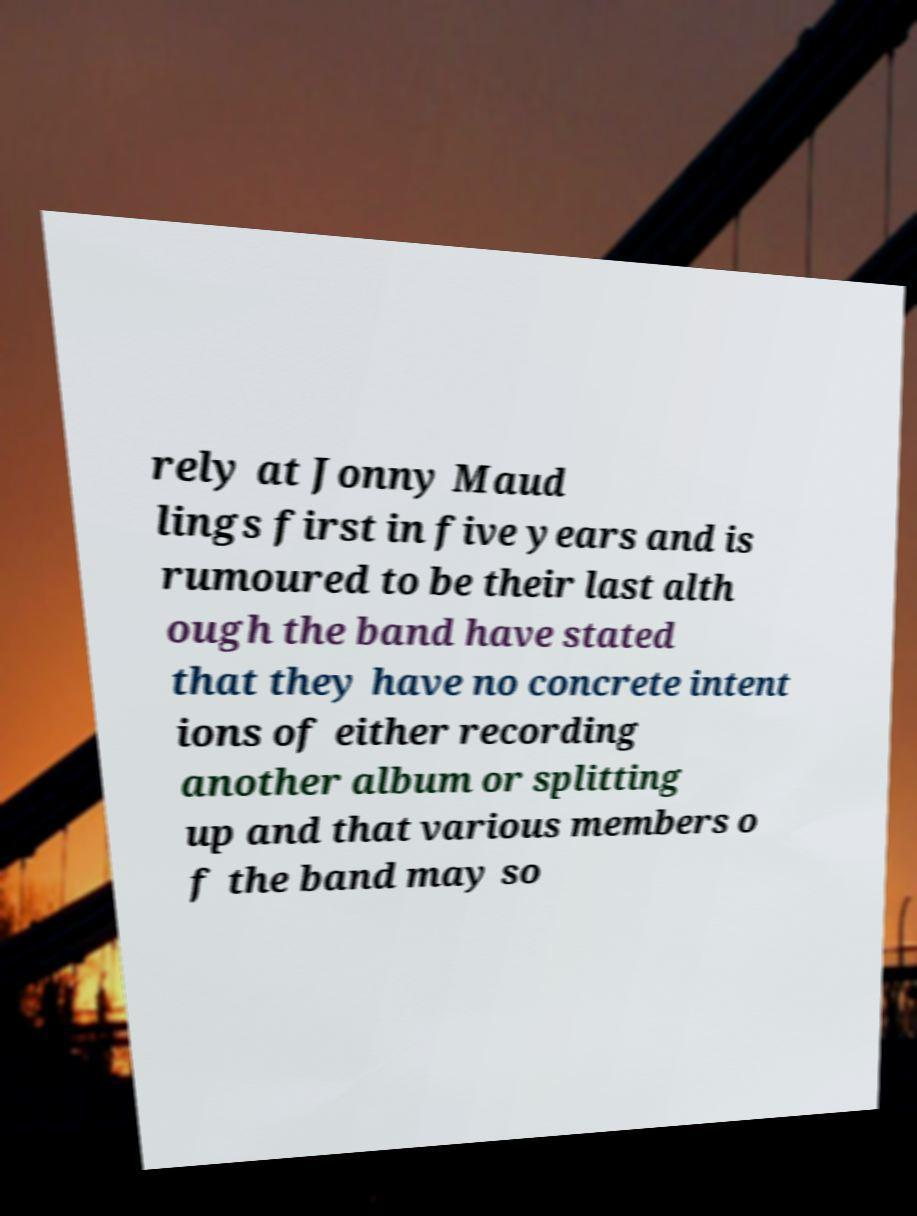Can you accurately transcribe the text from the provided image for me? rely at Jonny Maud lings first in five years and is rumoured to be their last alth ough the band have stated that they have no concrete intent ions of either recording another album or splitting up and that various members o f the band may so 